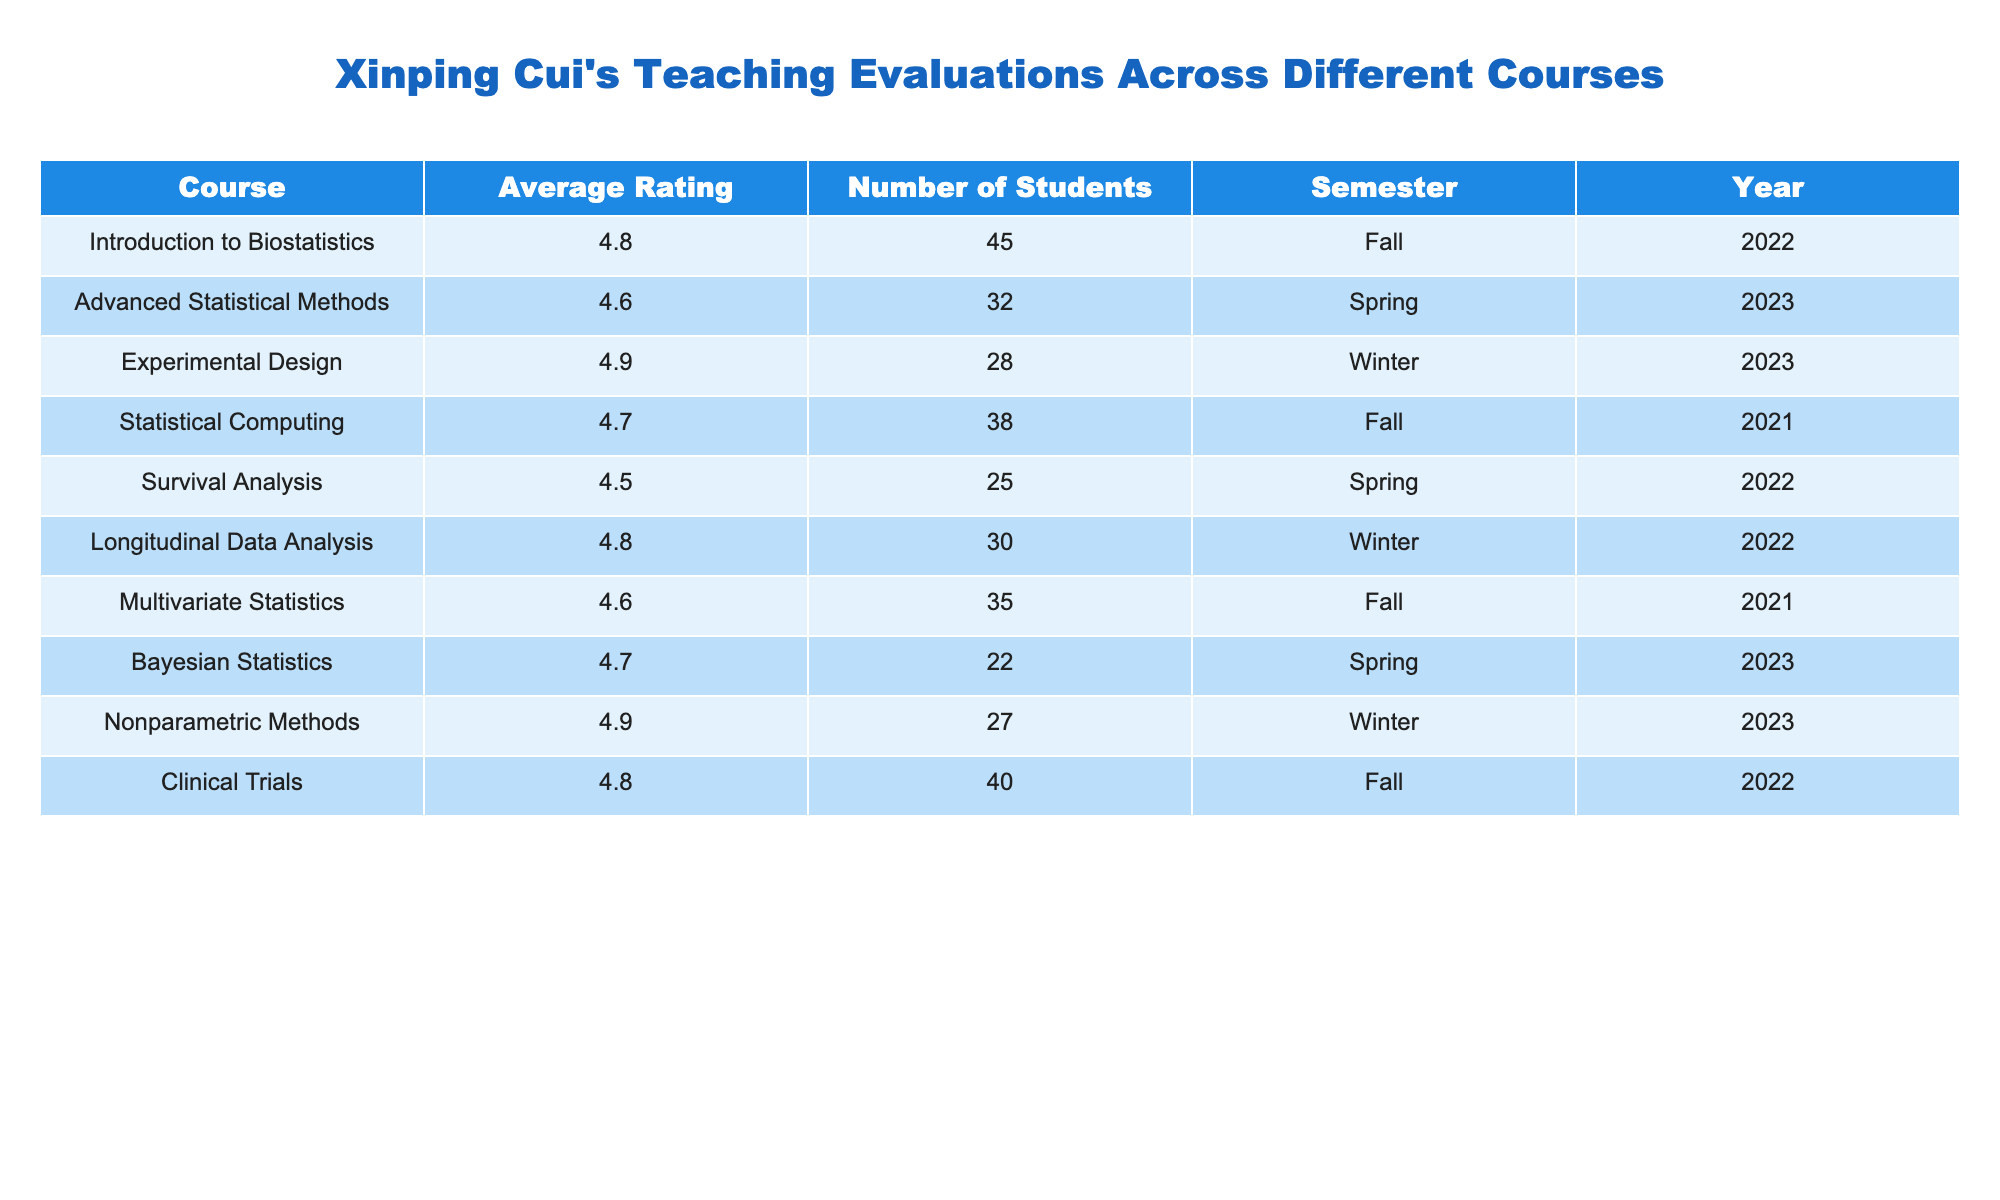What is the highest average rating among Xinping Cui's courses? By looking at the "Average Rating" column, we can find the maximum value, which is 4.9 for the courses "Experimental Design" and "Nonparametric Methods".
Answer: 4.9 Which course had the lowest average rating? Scanning the "Average Rating" column, the lowest value is 4.5 for "Survival Analysis".
Answer: Survival Analysis How many students evaluated the "Clinical Trials" course? The table indicates that 40 students evaluated the "Clinical Trials" course, as seen in the "Number of Students" column.
Answer: 40 What is the average rating for courses taught in Spring? The average ratings for the Spring courses are 4.6 (Advanced Statistical Methods) and 4.7 (Bayesian Statistics). To find the average: (4.6 + 4.7) / 2 = 4.65.
Answer: 4.65 Is "Statistical Computing" rated higher than "Survival Analysis"? The average rating for "Statistical Computing" is 4.7 while "Survival Analysis" is rated at 4.5. Since 4.7 > 4.5, it is true.
Answer: Yes How does the average rating of "Introduction to Biostatistics" compare to "Longitudinal Data Analysis"? The average rating for "Introduction to Biostatistics" is 4.8, and for "Longitudinal Data Analysis", it is also 4.8. Since both are equal, their ratings are the same.
Answer: They are equal What was the total number of students across all courses? To find this, we sum the "Number of Students" for all courses: 45 + 32 + 28 + 38 + 25 + 30 + 35 + 22 + 27 + 40 = 347.
Answer: 347 Which semester had the highest average rating? The average ratings per semester are: Fall - (4.8 + 4.7 + 4.6 + 4.8) / 4 = 4.775, Spring - (4.6 + 4.7 + 4.5) / 3 = 4.6, and Winter - (4.9 + 4.8 + 4.9) / 3 = 4.8667. The highest average is in Winter.
Answer: Winter What course was taught in Fall 2021? By checking the table, "Statistical Computing" is listed under Fall 2021.
Answer: Statistical Computing What percentage of students rated "Nonparametric Methods"? The total number of enrollments is 347, and "Nonparametric Methods" had 27 students evaluate it. To find the percentage: (27/347) * 100 ≈ 7.78%.
Answer: 7.78% 